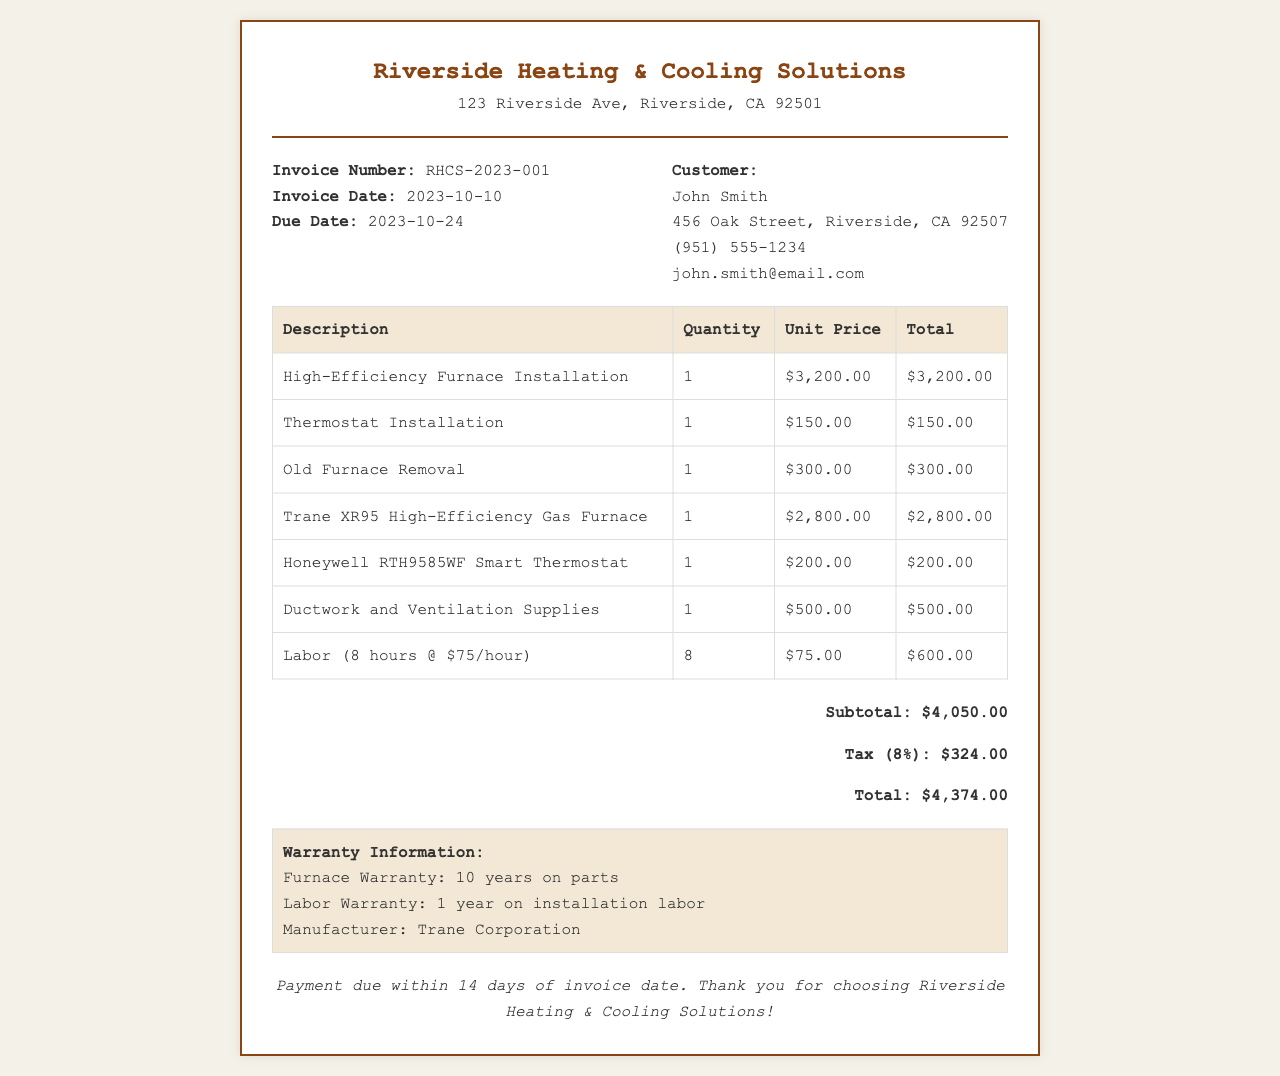What is the invoice number? The invoice number is listed prominently in the invoice details section.
Answer: RHCS-2023-001 What is the total amount due? The total amount due is provided at the end of the invoice after calculating the subtotal and tax.
Answer: $4,374.00 Who is the customer? The customer's name is given in the customer details section of the invoice.
Answer: John Smith What is the warranty duration for parts? The warranty information at the bottom specifies the duration for parts.
Answer: 10 years How much was charged for labor? The labor cost is summarized in the table with details on hours and rate.
Answer: $600.00 What is the installation date of the invoice? The invoice date is specified in the invoice details section.
Answer: 2023-10-10 What type of furnace was installed? The description of the installed furnace is available in the detailed parts list of the invoice.
Answer: Trane XR95 High-Efficiency Gas Furnace What is the tax rate applied? The document specifies the tax calculation in the total section of the invoice.
Answer: 8% When is the payment due? This detail is mentioned at the end of the invoice regarding payment timelines.
Answer: 2023-10-24 